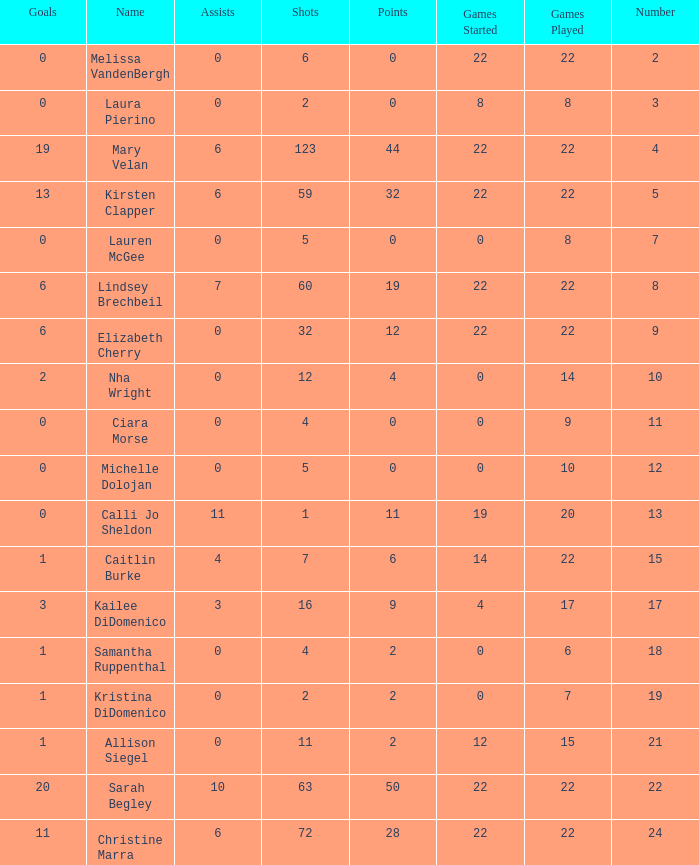How many numbers belong to the player with 10 assists?  1.0. 